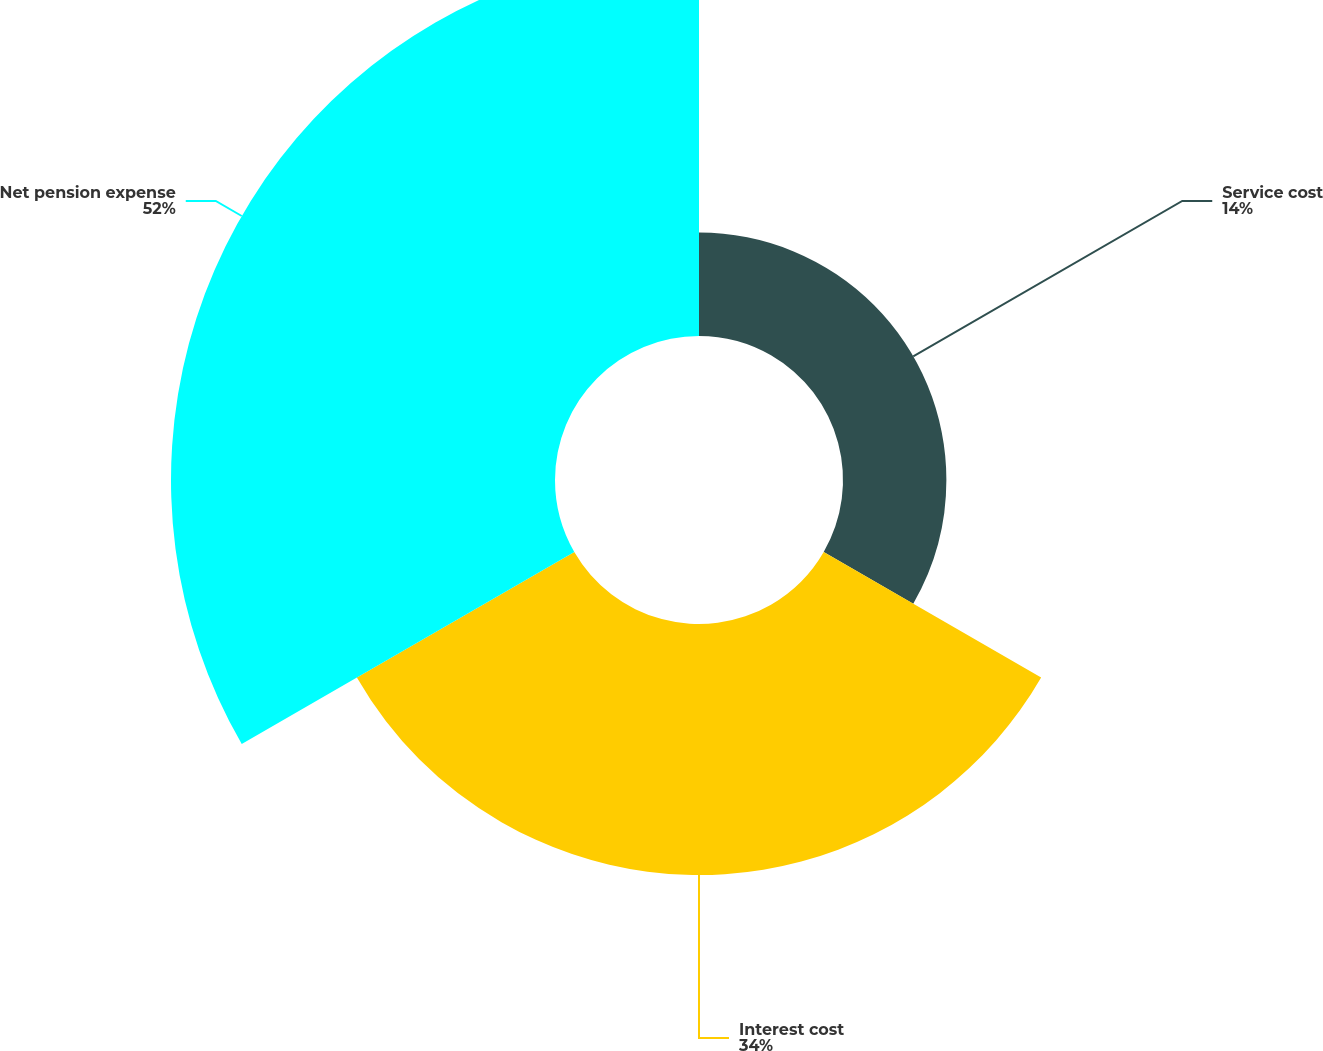Convert chart. <chart><loc_0><loc_0><loc_500><loc_500><pie_chart><fcel>Service cost<fcel>Interest cost<fcel>Net pension expense<nl><fcel>14.0%<fcel>34.0%<fcel>52.0%<nl></chart> 